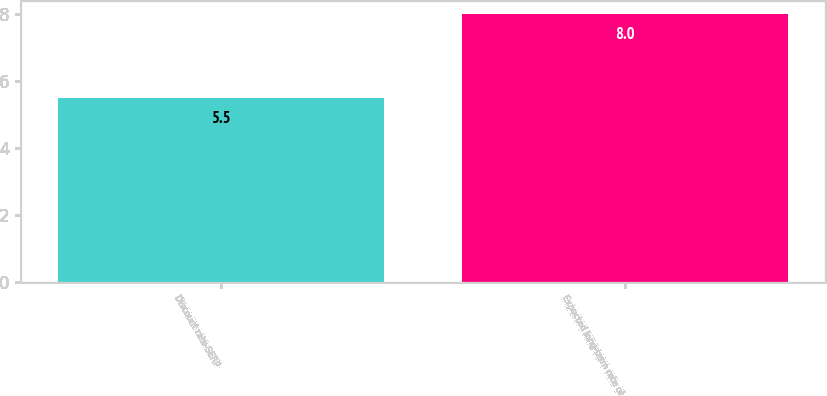Convert chart to OTSL. <chart><loc_0><loc_0><loc_500><loc_500><bar_chart><fcel>Discount rate-SERP<fcel>Expected long-term rate of<nl><fcel>5.5<fcel>8<nl></chart> 